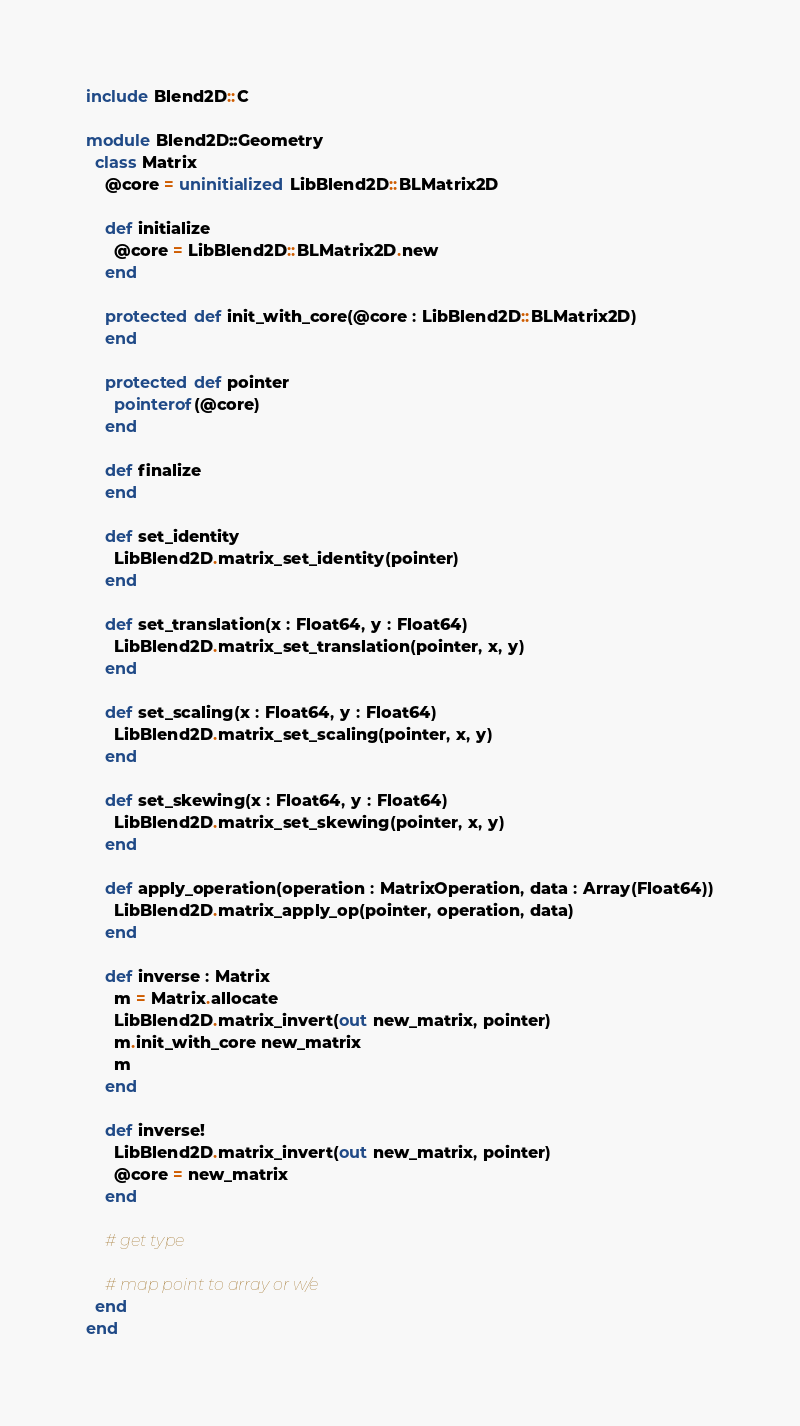Convert code to text. <code><loc_0><loc_0><loc_500><loc_500><_Crystal_>include Blend2D::C

module Blend2D::Geometry
  class Matrix
    @core = uninitialized LibBlend2D::BLMatrix2D

    def initialize
      @core = LibBlend2D::BLMatrix2D.new
    end

    protected def init_with_core(@core : LibBlend2D::BLMatrix2D)
    end

    protected def pointer
      pointerof(@core)
    end

    def finalize
    end

    def set_identity
      LibBlend2D.matrix_set_identity(pointer)
    end

    def set_translation(x : Float64, y : Float64)
      LibBlend2D.matrix_set_translation(pointer, x, y)
    end

    def set_scaling(x : Float64, y : Float64)
      LibBlend2D.matrix_set_scaling(pointer, x, y)
    end

    def set_skewing(x : Float64, y : Float64)
      LibBlend2D.matrix_set_skewing(pointer, x, y)
    end

    def apply_operation(operation : MatrixOperation, data : Array(Float64))
      LibBlend2D.matrix_apply_op(pointer, operation, data)
    end

    def inverse : Matrix
      m = Matrix.allocate
      LibBlend2D.matrix_invert(out new_matrix, pointer)
      m.init_with_core new_matrix
      m
    end

    def inverse!
      LibBlend2D.matrix_invert(out new_matrix, pointer)
      @core = new_matrix
    end

    # get type

    # map point to array or w/e
  end
end
</code> 